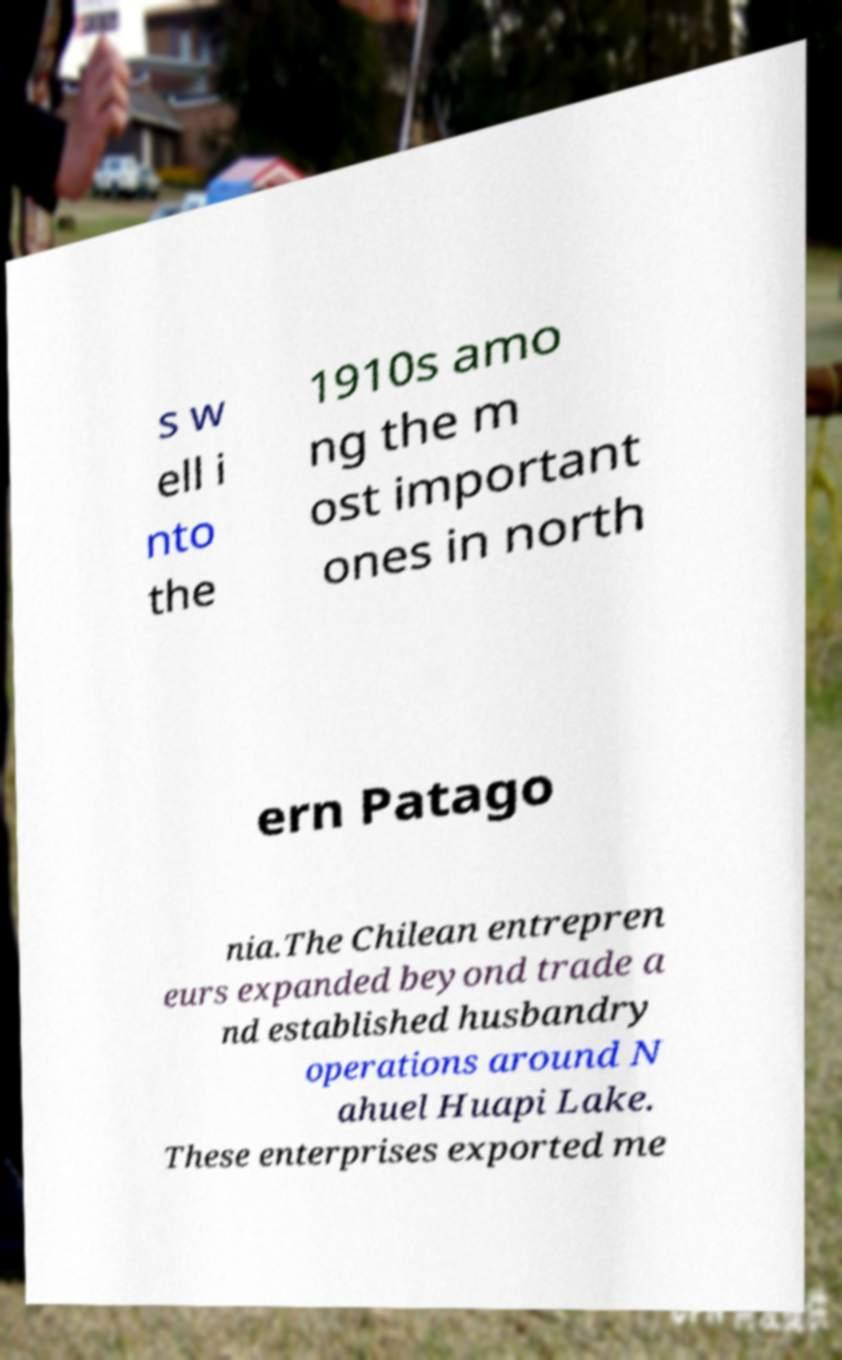I need the written content from this picture converted into text. Can you do that? s w ell i nto the 1910s amo ng the m ost important ones in north ern Patago nia.The Chilean entrepren eurs expanded beyond trade a nd established husbandry operations around N ahuel Huapi Lake. These enterprises exported me 